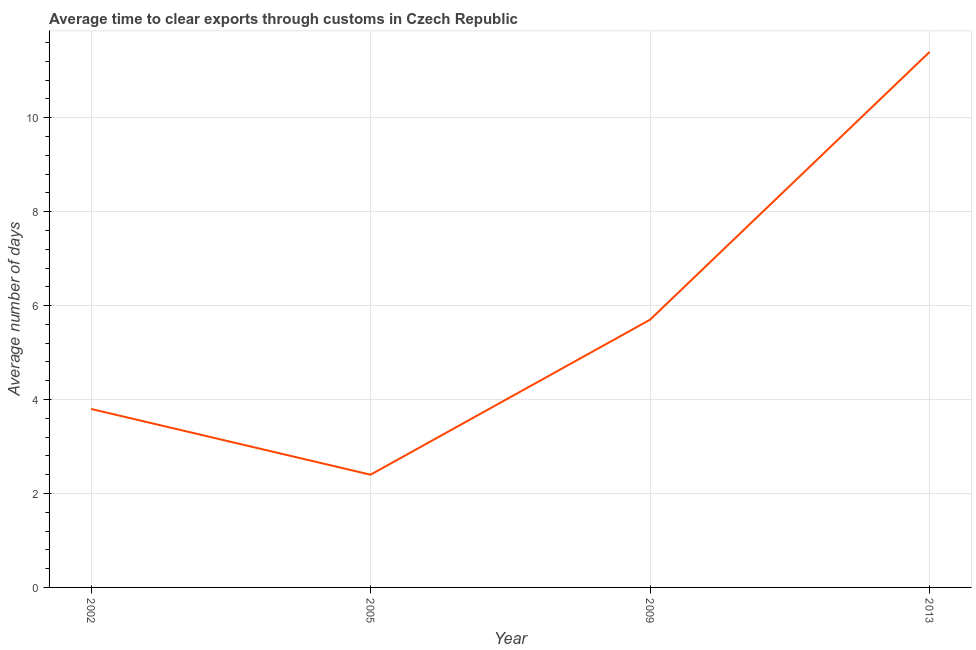In which year was the time to clear exports through customs maximum?
Give a very brief answer. 2013. In which year was the time to clear exports through customs minimum?
Offer a terse response. 2005. What is the sum of the time to clear exports through customs?
Ensure brevity in your answer.  23.3. What is the average time to clear exports through customs per year?
Offer a terse response. 5.82. What is the median time to clear exports through customs?
Make the answer very short. 4.75. In how many years, is the time to clear exports through customs greater than 11.2 days?
Give a very brief answer. 1. Do a majority of the years between 2013 and 2005 (inclusive) have time to clear exports through customs greater than 4.8 days?
Your response must be concise. No. What is the ratio of the time to clear exports through customs in 2009 to that in 2013?
Keep it short and to the point. 0.5. Is the difference between the time to clear exports through customs in 2005 and 2013 greater than the difference between any two years?
Provide a short and direct response. Yes. What is the difference between the highest and the lowest time to clear exports through customs?
Your answer should be very brief. 9. In how many years, is the time to clear exports through customs greater than the average time to clear exports through customs taken over all years?
Your answer should be compact. 1. Does the time to clear exports through customs monotonically increase over the years?
Your answer should be very brief. No. How many lines are there?
Ensure brevity in your answer.  1. What is the difference between two consecutive major ticks on the Y-axis?
Your answer should be very brief. 2. What is the title of the graph?
Keep it short and to the point. Average time to clear exports through customs in Czech Republic. What is the label or title of the X-axis?
Your response must be concise. Year. What is the label or title of the Y-axis?
Your answer should be compact. Average number of days. What is the Average number of days of 2002?
Offer a terse response. 3.8. What is the Average number of days of 2005?
Provide a succinct answer. 2.4. What is the Average number of days of 2013?
Give a very brief answer. 11.4. What is the difference between the Average number of days in 2002 and 2009?
Your response must be concise. -1.9. What is the difference between the Average number of days in 2002 and 2013?
Give a very brief answer. -7.6. What is the difference between the Average number of days in 2005 and 2009?
Provide a succinct answer. -3.3. What is the difference between the Average number of days in 2009 and 2013?
Offer a terse response. -5.7. What is the ratio of the Average number of days in 2002 to that in 2005?
Provide a short and direct response. 1.58. What is the ratio of the Average number of days in 2002 to that in 2009?
Keep it short and to the point. 0.67. What is the ratio of the Average number of days in 2002 to that in 2013?
Give a very brief answer. 0.33. What is the ratio of the Average number of days in 2005 to that in 2009?
Give a very brief answer. 0.42. What is the ratio of the Average number of days in 2005 to that in 2013?
Ensure brevity in your answer.  0.21. What is the ratio of the Average number of days in 2009 to that in 2013?
Offer a very short reply. 0.5. 